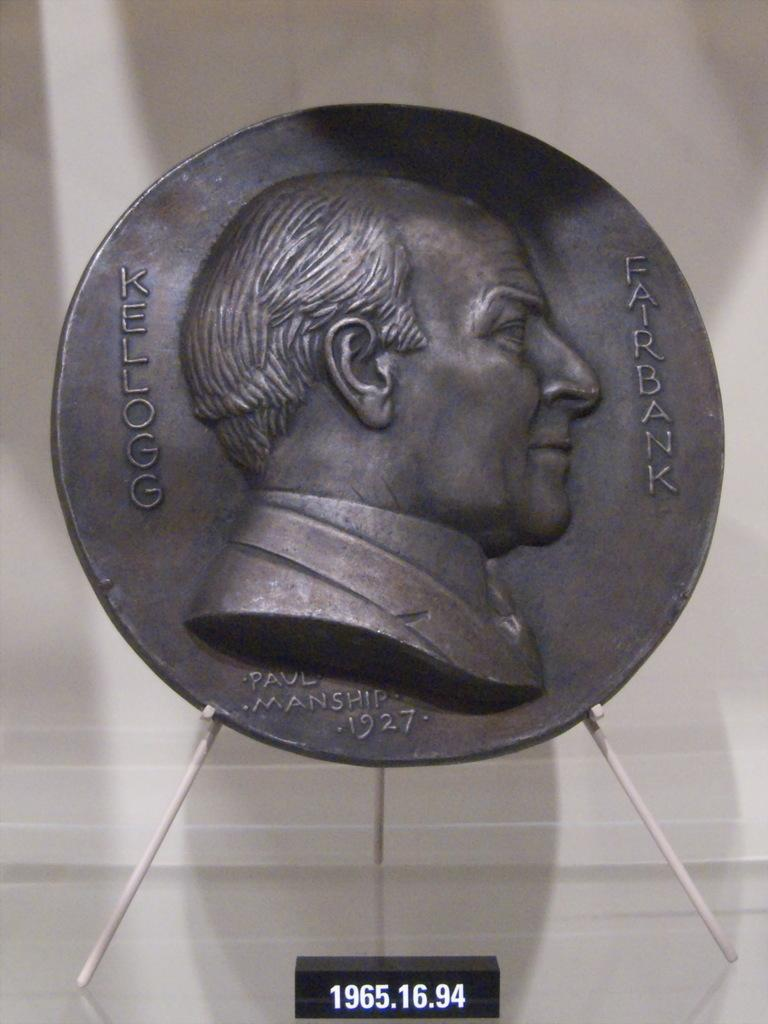<image>
Present a compact description of the photo's key features. A bronze plated seal that features the bust of Paul Manship. 